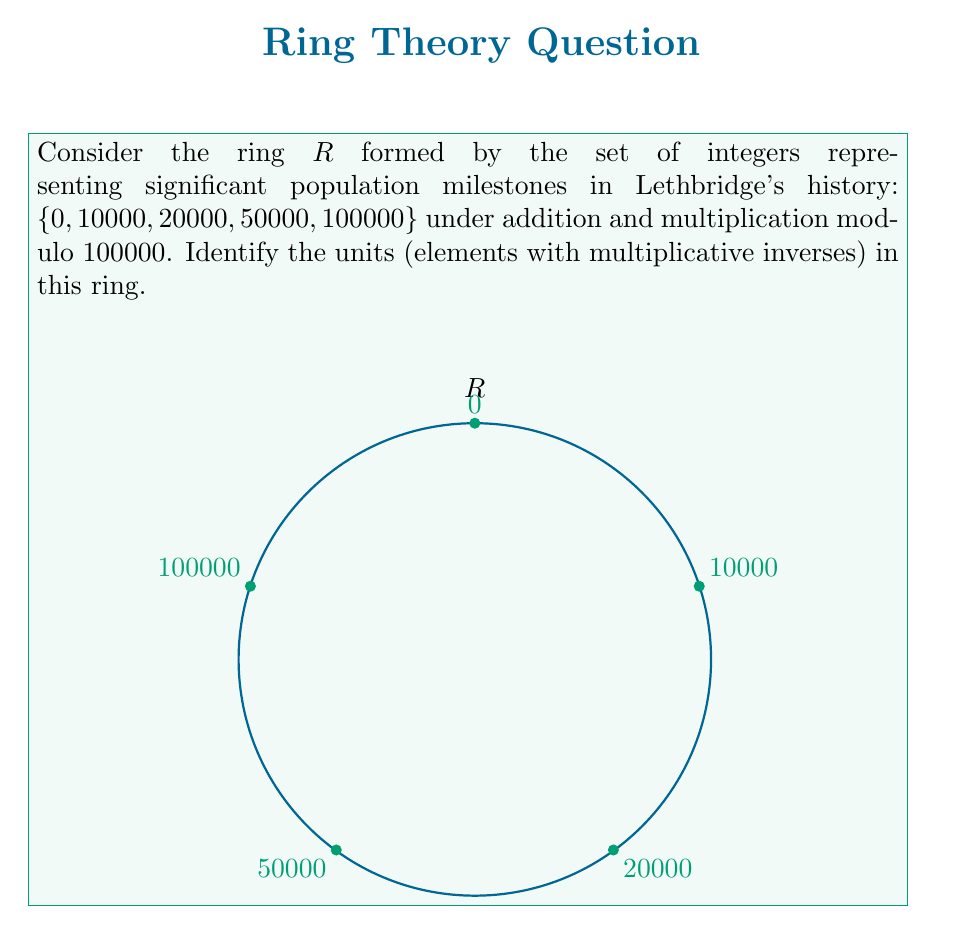Can you answer this question? Let's approach this step-by-step:

1) In a ring, a unit is an element that has a multiplicative inverse. In other words, for an element $a$ to be a unit, there must exist an element $b$ such that $ab \equiv 1 \pmod{100000}$.

2) Let's check each element:

   a) 0: Cannot be a unit as it has no multiplicative inverse.
   
   b) 10000: 
      $10000 \cdot 10000 \equiv 0 \pmod{100000}$
      Not a unit.
   
   c) 20000:
      $20000 \cdot 5 \equiv 0 \pmod{100000}$
      Not a unit.
   
   d) 50000:
      $50000 \cdot 2 \equiv 0 \pmod{100000}$
      Not a unit.
   
   e) 100000:
      $100000 \equiv 0 \pmod{100000}$
      Not a unit.

3) None of the elements in the ring have multiplicative inverses modulo 100000.

4) This is because all elements in the ring are factors of 100000, and therefore their product with any other element will always be divisible by 100000, resulting in 0 modulo 100000.

5) In ring theory, we typically include 1 as a unit by definition. However, 1 is not part of this ring based on the given set.

Therefore, this ring has no units.
Answer: $\{\}$ (empty set) 